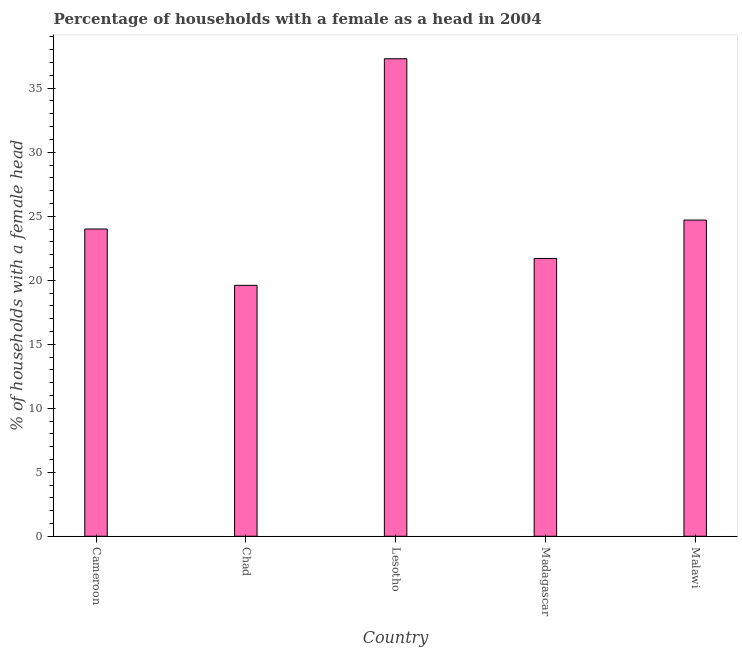What is the title of the graph?
Offer a very short reply. Percentage of households with a female as a head in 2004. What is the label or title of the X-axis?
Make the answer very short. Country. What is the label or title of the Y-axis?
Provide a short and direct response. % of households with a female head. Across all countries, what is the maximum number of female supervised households?
Your answer should be very brief. 37.3. Across all countries, what is the minimum number of female supervised households?
Offer a very short reply. 19.6. In which country was the number of female supervised households maximum?
Offer a terse response. Lesotho. In which country was the number of female supervised households minimum?
Provide a short and direct response. Chad. What is the sum of the number of female supervised households?
Provide a short and direct response. 127.3. What is the average number of female supervised households per country?
Keep it short and to the point. 25.46. Is the number of female supervised households in Lesotho less than that in Malawi?
Make the answer very short. No. What is the difference between the highest and the second highest number of female supervised households?
Your answer should be very brief. 12.6. What is the difference between the highest and the lowest number of female supervised households?
Give a very brief answer. 17.7. In how many countries, is the number of female supervised households greater than the average number of female supervised households taken over all countries?
Your answer should be compact. 1. Are all the bars in the graph horizontal?
Provide a short and direct response. No. How many countries are there in the graph?
Offer a terse response. 5. Are the values on the major ticks of Y-axis written in scientific E-notation?
Your response must be concise. No. What is the % of households with a female head in Cameroon?
Offer a terse response. 24. What is the % of households with a female head of Chad?
Ensure brevity in your answer.  19.6. What is the % of households with a female head of Lesotho?
Make the answer very short. 37.3. What is the % of households with a female head of Madagascar?
Keep it short and to the point. 21.7. What is the % of households with a female head of Malawi?
Ensure brevity in your answer.  24.7. What is the difference between the % of households with a female head in Cameroon and Chad?
Ensure brevity in your answer.  4.4. What is the difference between the % of households with a female head in Chad and Lesotho?
Give a very brief answer. -17.7. What is the difference between the % of households with a female head in Lesotho and Malawi?
Keep it short and to the point. 12.6. What is the difference between the % of households with a female head in Madagascar and Malawi?
Make the answer very short. -3. What is the ratio of the % of households with a female head in Cameroon to that in Chad?
Offer a very short reply. 1.22. What is the ratio of the % of households with a female head in Cameroon to that in Lesotho?
Make the answer very short. 0.64. What is the ratio of the % of households with a female head in Cameroon to that in Madagascar?
Keep it short and to the point. 1.11. What is the ratio of the % of households with a female head in Chad to that in Lesotho?
Offer a very short reply. 0.53. What is the ratio of the % of households with a female head in Chad to that in Madagascar?
Provide a succinct answer. 0.9. What is the ratio of the % of households with a female head in Chad to that in Malawi?
Offer a very short reply. 0.79. What is the ratio of the % of households with a female head in Lesotho to that in Madagascar?
Your response must be concise. 1.72. What is the ratio of the % of households with a female head in Lesotho to that in Malawi?
Provide a succinct answer. 1.51. What is the ratio of the % of households with a female head in Madagascar to that in Malawi?
Give a very brief answer. 0.88. 